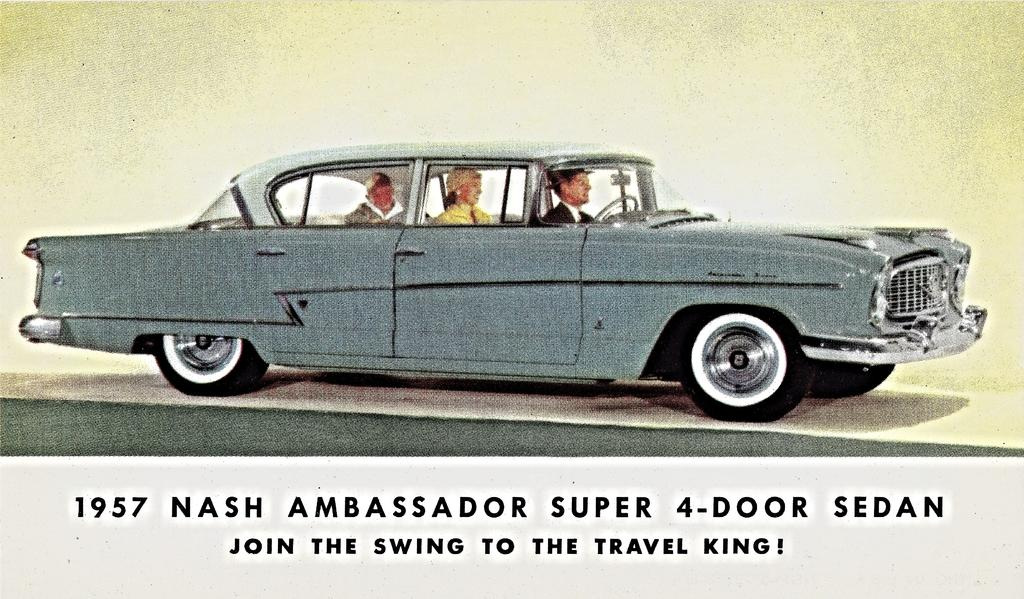What can be seen in the image besides the car? There is some text in the image. What is the main subject of the image? The main subject of the image is a car. What is happening with the people in the image? There are people sitting in the car. What type of berry is being discussed by the people in the car? There is no indication in the image that the people in the car are discussing any type of berry. 